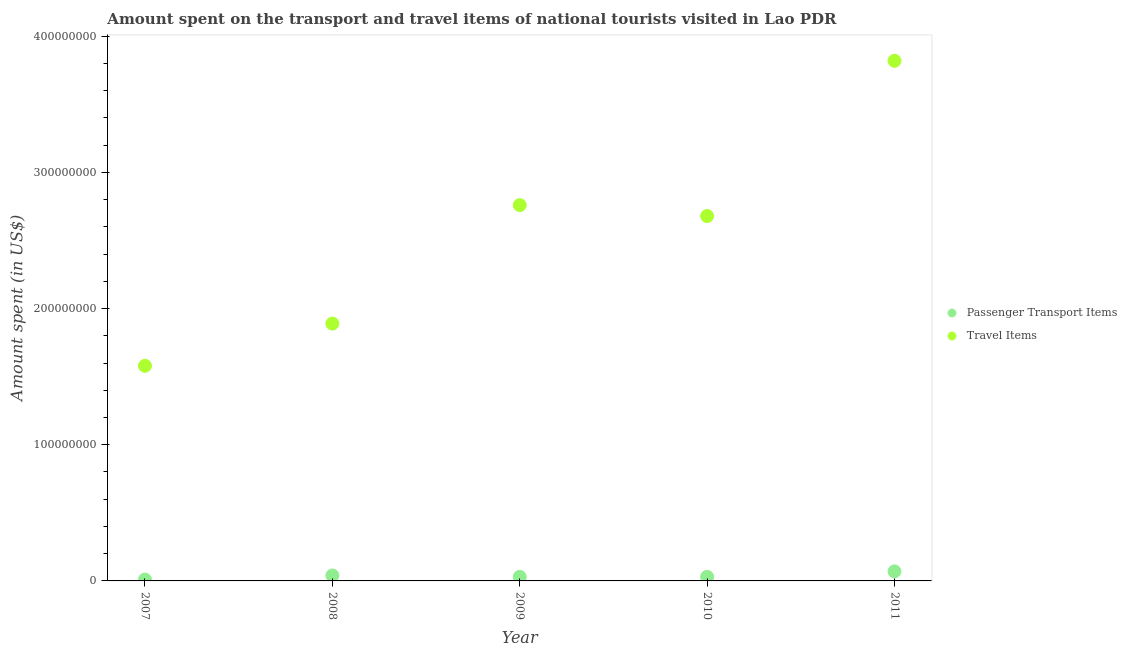Is the number of dotlines equal to the number of legend labels?
Keep it short and to the point. Yes. What is the amount spent on passenger transport items in 2010?
Provide a short and direct response. 3.00e+06. Across all years, what is the maximum amount spent on passenger transport items?
Offer a very short reply. 7.00e+06. Across all years, what is the minimum amount spent in travel items?
Your answer should be very brief. 1.58e+08. In which year was the amount spent on passenger transport items maximum?
Your response must be concise. 2011. What is the total amount spent in travel items in the graph?
Provide a succinct answer. 1.27e+09. What is the difference between the amount spent on passenger transport items in 2007 and that in 2009?
Provide a short and direct response. -2.00e+06. What is the difference between the amount spent on passenger transport items in 2011 and the amount spent in travel items in 2008?
Provide a short and direct response. -1.82e+08. What is the average amount spent in travel items per year?
Give a very brief answer. 2.55e+08. In the year 2011, what is the difference between the amount spent on passenger transport items and amount spent in travel items?
Your response must be concise. -3.75e+08. What is the difference between the highest and the second highest amount spent on passenger transport items?
Your answer should be compact. 3.00e+06. What is the difference between the highest and the lowest amount spent in travel items?
Provide a short and direct response. 2.24e+08. Does the amount spent in travel items monotonically increase over the years?
Provide a short and direct response. No. Is the amount spent in travel items strictly greater than the amount spent on passenger transport items over the years?
Your answer should be very brief. Yes. How many dotlines are there?
Give a very brief answer. 2. Are the values on the major ticks of Y-axis written in scientific E-notation?
Make the answer very short. No. Does the graph contain any zero values?
Your answer should be very brief. No. Where does the legend appear in the graph?
Your answer should be compact. Center right. How many legend labels are there?
Give a very brief answer. 2. How are the legend labels stacked?
Ensure brevity in your answer.  Vertical. What is the title of the graph?
Ensure brevity in your answer.  Amount spent on the transport and travel items of national tourists visited in Lao PDR. Does "Drinking water services" appear as one of the legend labels in the graph?
Keep it short and to the point. No. What is the label or title of the Y-axis?
Provide a succinct answer. Amount spent (in US$). What is the Amount spent (in US$) in Passenger Transport Items in 2007?
Give a very brief answer. 1.00e+06. What is the Amount spent (in US$) of Travel Items in 2007?
Your answer should be very brief. 1.58e+08. What is the Amount spent (in US$) in Passenger Transport Items in 2008?
Ensure brevity in your answer.  4.00e+06. What is the Amount spent (in US$) of Travel Items in 2008?
Your answer should be compact. 1.89e+08. What is the Amount spent (in US$) in Passenger Transport Items in 2009?
Ensure brevity in your answer.  3.00e+06. What is the Amount spent (in US$) of Travel Items in 2009?
Offer a terse response. 2.76e+08. What is the Amount spent (in US$) of Passenger Transport Items in 2010?
Offer a terse response. 3.00e+06. What is the Amount spent (in US$) of Travel Items in 2010?
Offer a very short reply. 2.68e+08. What is the Amount spent (in US$) in Passenger Transport Items in 2011?
Offer a very short reply. 7.00e+06. What is the Amount spent (in US$) of Travel Items in 2011?
Keep it short and to the point. 3.82e+08. Across all years, what is the maximum Amount spent (in US$) of Passenger Transport Items?
Provide a succinct answer. 7.00e+06. Across all years, what is the maximum Amount spent (in US$) of Travel Items?
Your answer should be compact. 3.82e+08. Across all years, what is the minimum Amount spent (in US$) in Passenger Transport Items?
Ensure brevity in your answer.  1.00e+06. Across all years, what is the minimum Amount spent (in US$) in Travel Items?
Offer a terse response. 1.58e+08. What is the total Amount spent (in US$) of Passenger Transport Items in the graph?
Make the answer very short. 1.80e+07. What is the total Amount spent (in US$) in Travel Items in the graph?
Keep it short and to the point. 1.27e+09. What is the difference between the Amount spent (in US$) of Passenger Transport Items in 2007 and that in 2008?
Offer a very short reply. -3.00e+06. What is the difference between the Amount spent (in US$) in Travel Items in 2007 and that in 2008?
Ensure brevity in your answer.  -3.10e+07. What is the difference between the Amount spent (in US$) of Passenger Transport Items in 2007 and that in 2009?
Provide a short and direct response. -2.00e+06. What is the difference between the Amount spent (in US$) of Travel Items in 2007 and that in 2009?
Give a very brief answer. -1.18e+08. What is the difference between the Amount spent (in US$) in Travel Items in 2007 and that in 2010?
Keep it short and to the point. -1.10e+08. What is the difference between the Amount spent (in US$) of Passenger Transport Items in 2007 and that in 2011?
Provide a succinct answer. -6.00e+06. What is the difference between the Amount spent (in US$) of Travel Items in 2007 and that in 2011?
Ensure brevity in your answer.  -2.24e+08. What is the difference between the Amount spent (in US$) of Travel Items in 2008 and that in 2009?
Give a very brief answer. -8.70e+07. What is the difference between the Amount spent (in US$) of Travel Items in 2008 and that in 2010?
Your response must be concise. -7.90e+07. What is the difference between the Amount spent (in US$) in Passenger Transport Items in 2008 and that in 2011?
Provide a short and direct response. -3.00e+06. What is the difference between the Amount spent (in US$) of Travel Items in 2008 and that in 2011?
Offer a very short reply. -1.93e+08. What is the difference between the Amount spent (in US$) in Passenger Transport Items in 2009 and that in 2010?
Your response must be concise. 0. What is the difference between the Amount spent (in US$) of Passenger Transport Items in 2009 and that in 2011?
Ensure brevity in your answer.  -4.00e+06. What is the difference between the Amount spent (in US$) in Travel Items in 2009 and that in 2011?
Give a very brief answer. -1.06e+08. What is the difference between the Amount spent (in US$) in Passenger Transport Items in 2010 and that in 2011?
Provide a short and direct response. -4.00e+06. What is the difference between the Amount spent (in US$) in Travel Items in 2010 and that in 2011?
Offer a terse response. -1.14e+08. What is the difference between the Amount spent (in US$) in Passenger Transport Items in 2007 and the Amount spent (in US$) in Travel Items in 2008?
Offer a terse response. -1.88e+08. What is the difference between the Amount spent (in US$) in Passenger Transport Items in 2007 and the Amount spent (in US$) in Travel Items in 2009?
Provide a short and direct response. -2.75e+08. What is the difference between the Amount spent (in US$) of Passenger Transport Items in 2007 and the Amount spent (in US$) of Travel Items in 2010?
Offer a very short reply. -2.67e+08. What is the difference between the Amount spent (in US$) in Passenger Transport Items in 2007 and the Amount spent (in US$) in Travel Items in 2011?
Make the answer very short. -3.81e+08. What is the difference between the Amount spent (in US$) in Passenger Transport Items in 2008 and the Amount spent (in US$) in Travel Items in 2009?
Offer a terse response. -2.72e+08. What is the difference between the Amount spent (in US$) of Passenger Transport Items in 2008 and the Amount spent (in US$) of Travel Items in 2010?
Your response must be concise. -2.64e+08. What is the difference between the Amount spent (in US$) in Passenger Transport Items in 2008 and the Amount spent (in US$) in Travel Items in 2011?
Ensure brevity in your answer.  -3.78e+08. What is the difference between the Amount spent (in US$) in Passenger Transport Items in 2009 and the Amount spent (in US$) in Travel Items in 2010?
Make the answer very short. -2.65e+08. What is the difference between the Amount spent (in US$) of Passenger Transport Items in 2009 and the Amount spent (in US$) of Travel Items in 2011?
Your answer should be very brief. -3.79e+08. What is the difference between the Amount spent (in US$) in Passenger Transport Items in 2010 and the Amount spent (in US$) in Travel Items in 2011?
Your response must be concise. -3.79e+08. What is the average Amount spent (in US$) of Passenger Transport Items per year?
Your response must be concise. 3.60e+06. What is the average Amount spent (in US$) in Travel Items per year?
Ensure brevity in your answer.  2.55e+08. In the year 2007, what is the difference between the Amount spent (in US$) in Passenger Transport Items and Amount spent (in US$) in Travel Items?
Provide a succinct answer. -1.57e+08. In the year 2008, what is the difference between the Amount spent (in US$) of Passenger Transport Items and Amount spent (in US$) of Travel Items?
Your answer should be compact. -1.85e+08. In the year 2009, what is the difference between the Amount spent (in US$) of Passenger Transport Items and Amount spent (in US$) of Travel Items?
Your response must be concise. -2.73e+08. In the year 2010, what is the difference between the Amount spent (in US$) in Passenger Transport Items and Amount spent (in US$) in Travel Items?
Your answer should be compact. -2.65e+08. In the year 2011, what is the difference between the Amount spent (in US$) of Passenger Transport Items and Amount spent (in US$) of Travel Items?
Offer a very short reply. -3.75e+08. What is the ratio of the Amount spent (in US$) in Passenger Transport Items in 2007 to that in 2008?
Your answer should be compact. 0.25. What is the ratio of the Amount spent (in US$) in Travel Items in 2007 to that in 2008?
Provide a succinct answer. 0.84. What is the ratio of the Amount spent (in US$) in Travel Items in 2007 to that in 2009?
Keep it short and to the point. 0.57. What is the ratio of the Amount spent (in US$) of Travel Items in 2007 to that in 2010?
Ensure brevity in your answer.  0.59. What is the ratio of the Amount spent (in US$) in Passenger Transport Items in 2007 to that in 2011?
Make the answer very short. 0.14. What is the ratio of the Amount spent (in US$) of Travel Items in 2007 to that in 2011?
Give a very brief answer. 0.41. What is the ratio of the Amount spent (in US$) in Travel Items in 2008 to that in 2009?
Provide a short and direct response. 0.68. What is the ratio of the Amount spent (in US$) of Travel Items in 2008 to that in 2010?
Provide a succinct answer. 0.71. What is the ratio of the Amount spent (in US$) of Passenger Transport Items in 2008 to that in 2011?
Give a very brief answer. 0.57. What is the ratio of the Amount spent (in US$) of Travel Items in 2008 to that in 2011?
Your answer should be compact. 0.49. What is the ratio of the Amount spent (in US$) of Travel Items in 2009 to that in 2010?
Ensure brevity in your answer.  1.03. What is the ratio of the Amount spent (in US$) in Passenger Transport Items in 2009 to that in 2011?
Your response must be concise. 0.43. What is the ratio of the Amount spent (in US$) of Travel Items in 2009 to that in 2011?
Keep it short and to the point. 0.72. What is the ratio of the Amount spent (in US$) of Passenger Transport Items in 2010 to that in 2011?
Offer a very short reply. 0.43. What is the ratio of the Amount spent (in US$) in Travel Items in 2010 to that in 2011?
Provide a short and direct response. 0.7. What is the difference between the highest and the second highest Amount spent (in US$) of Travel Items?
Make the answer very short. 1.06e+08. What is the difference between the highest and the lowest Amount spent (in US$) in Passenger Transport Items?
Keep it short and to the point. 6.00e+06. What is the difference between the highest and the lowest Amount spent (in US$) of Travel Items?
Provide a succinct answer. 2.24e+08. 